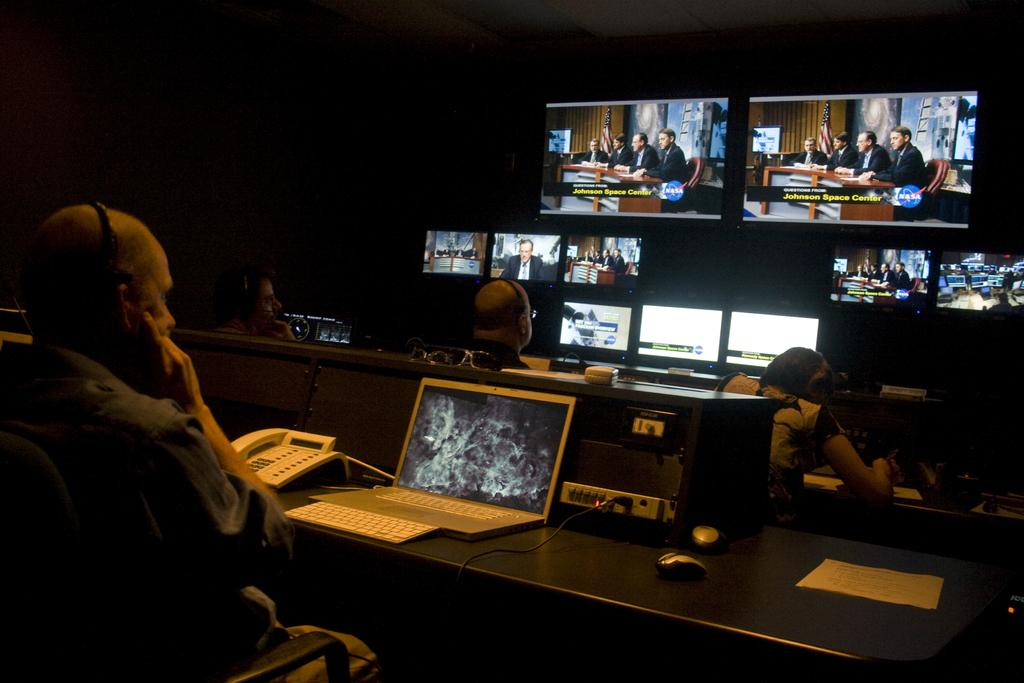What can be seen in the image? There are people, chairs, tables, screens, laptops, a telephone, mouses, papers, and objects in the image. What are the people doing in the image? The people are sitting on chairs in the image. What is the color of the background in the image? The background of the image is dark. Can you see any fish swimming in the image? No, there are no fish present in the image. Is there a snake slithering across the table in the image? No, there is no snake present in the image. 